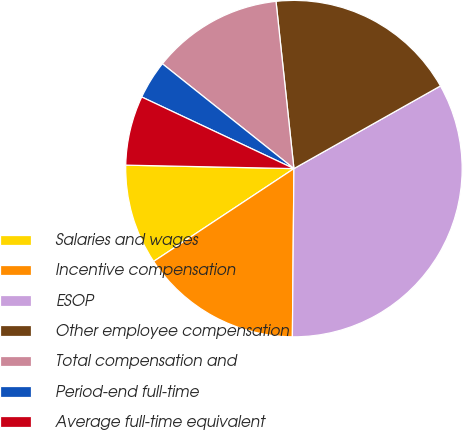Convert chart to OTSL. <chart><loc_0><loc_0><loc_500><loc_500><pie_chart><fcel>Salaries and wages<fcel>Incentive compensation<fcel>ESOP<fcel>Other employee compensation<fcel>Total compensation and<fcel>Period-end full-time<fcel>Average full-time equivalent<nl><fcel>9.63%<fcel>15.55%<fcel>33.32%<fcel>18.52%<fcel>12.59%<fcel>3.71%<fcel>6.67%<nl></chart> 